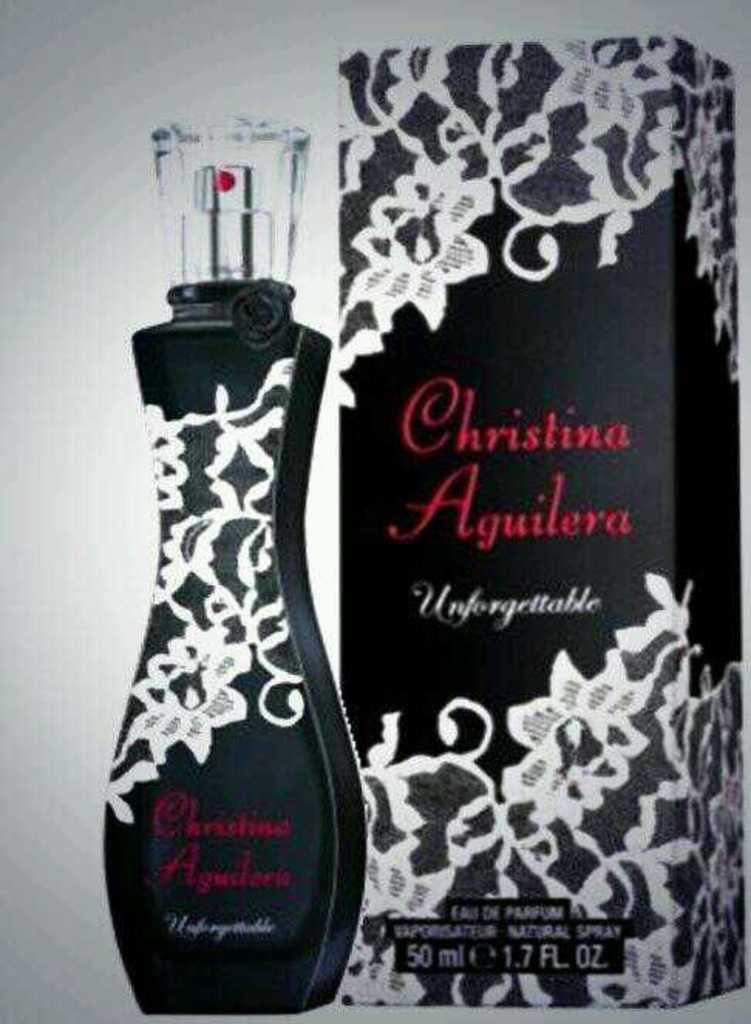Who is the celebrity name of the perfume?
Your response must be concise. Christina aguilera. How many ml is the bottle?
Provide a succinct answer. 50. 